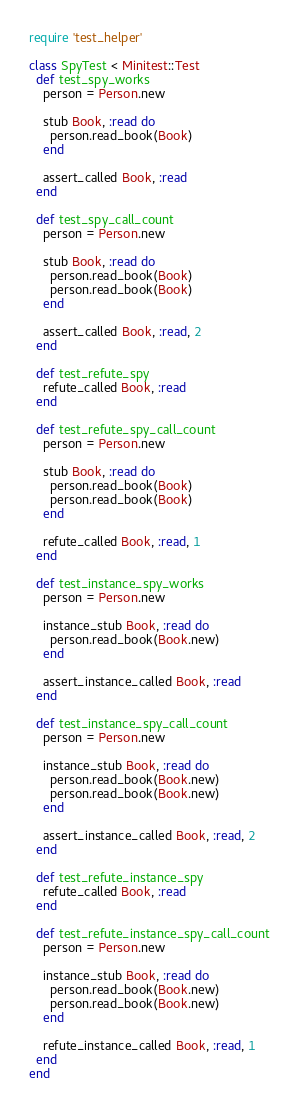Convert code to text. <code><loc_0><loc_0><loc_500><loc_500><_Ruby_>require 'test_helper'

class SpyTest < Minitest::Test
  def test_spy_works
    person = Person.new

    stub Book, :read do
      person.read_book(Book)
    end

    assert_called Book, :read
  end

  def test_spy_call_count
    person = Person.new

    stub Book, :read do
      person.read_book(Book)
      person.read_book(Book)
    end

    assert_called Book, :read, 2
  end

  def test_refute_spy
    refute_called Book, :read
  end

  def test_refute_spy_call_count
    person = Person.new

    stub Book, :read do
      person.read_book(Book)
      person.read_book(Book)
    end

    refute_called Book, :read, 1
  end

  def test_instance_spy_works
    person = Person.new

    instance_stub Book, :read do
      person.read_book(Book.new)
    end

    assert_instance_called Book, :read
  end

  def test_instance_spy_call_count
    person = Person.new

    instance_stub Book, :read do
      person.read_book(Book.new)
      person.read_book(Book.new)
    end

    assert_instance_called Book, :read, 2
  end

  def test_refute_instance_spy
    refute_called Book, :read
  end

  def test_refute_instance_spy_call_count
    person = Person.new

    instance_stub Book, :read do
      person.read_book(Book.new)
      person.read_book(Book.new)
    end

    refute_instance_called Book, :read, 1
  end
end
</code> 